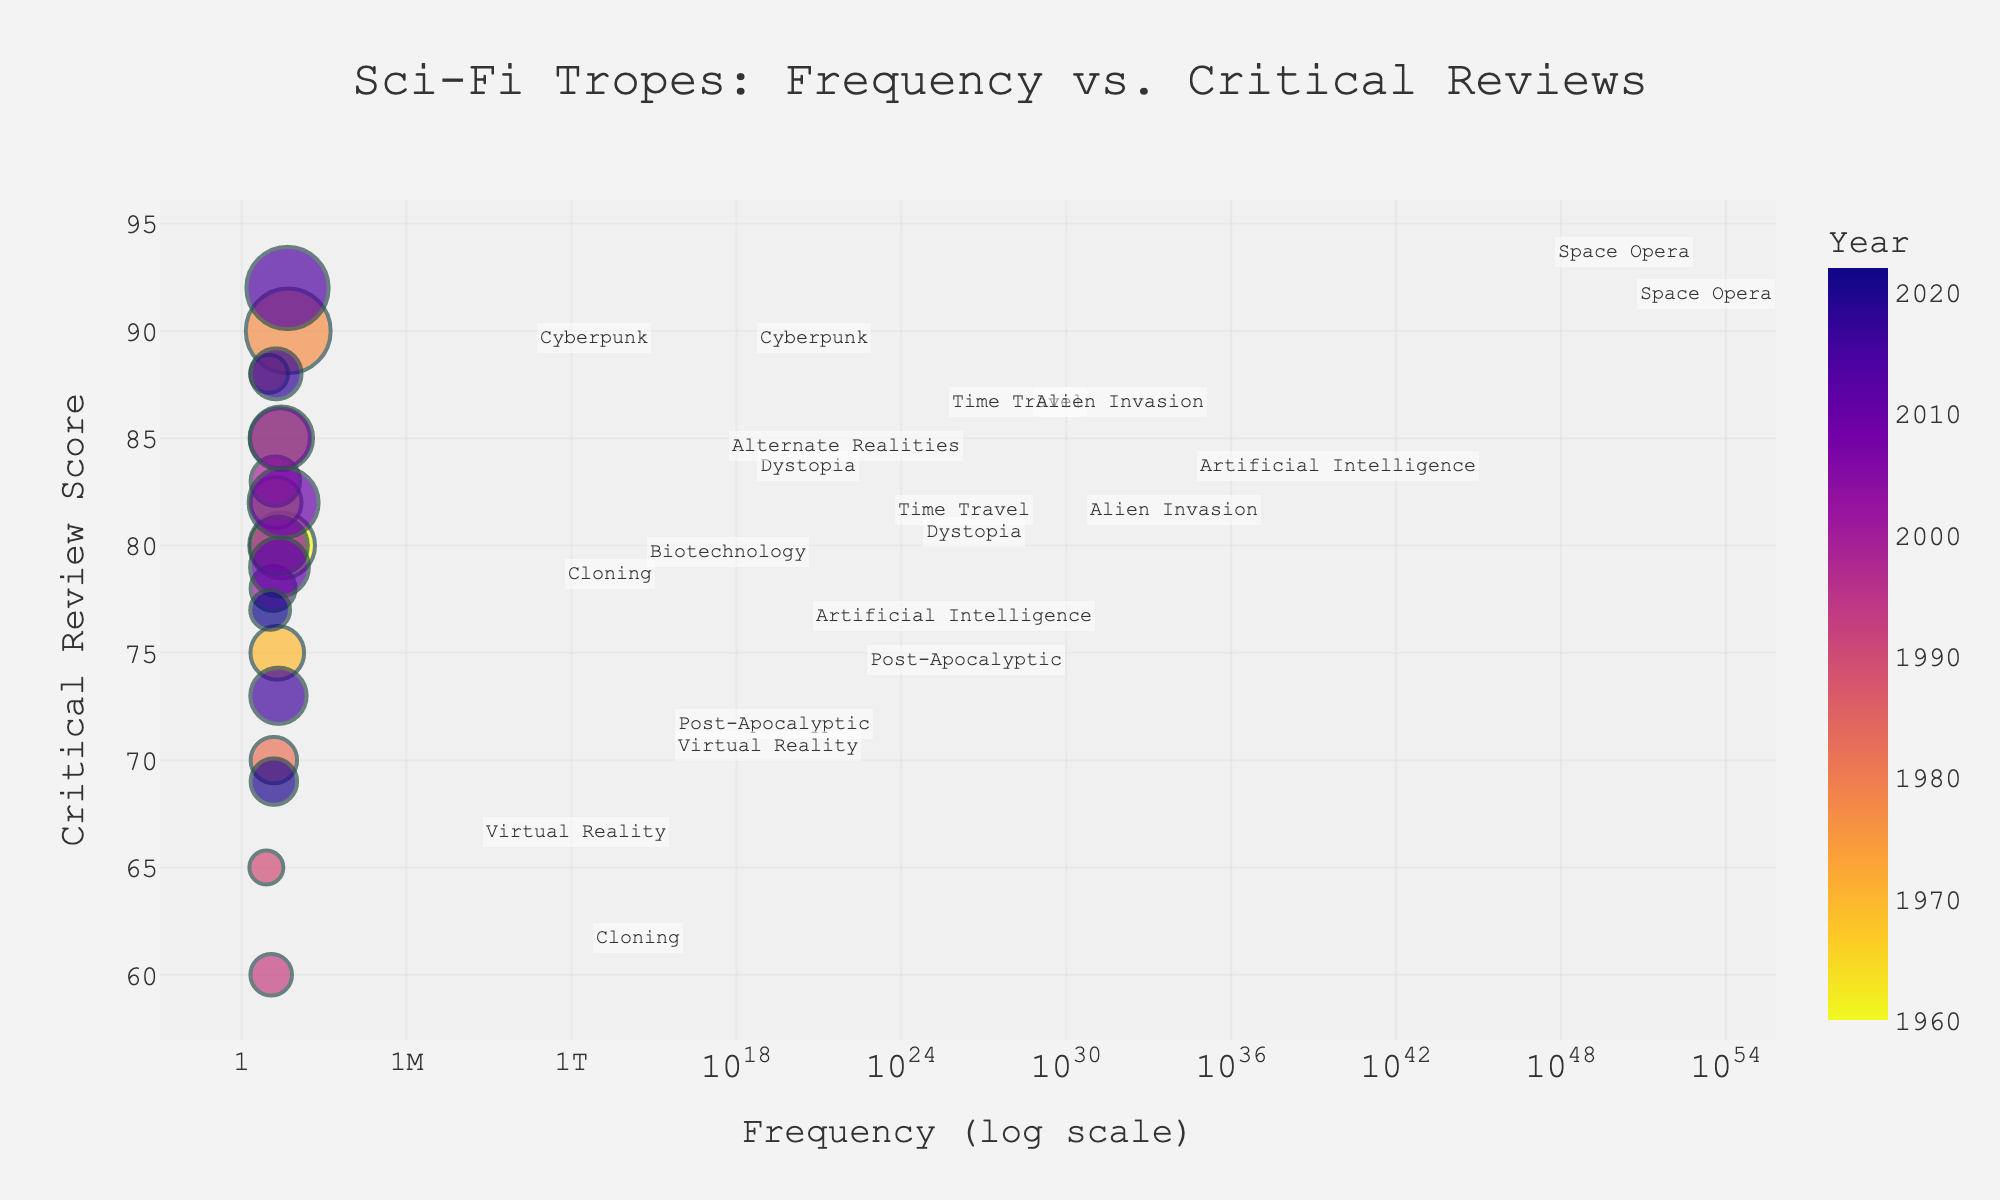What's the title of the scatter plot? The title of the plot is displayed prominently at the top center of the figure.
Answer: "Sci-Fi Tropes: Frequency vs. Critical Reviews" What are the axes titles in the scatter plot? The x-axis and y-axis titles are labeled clearly near the respective axes.
Answer: Frequency (log scale), Critical Review Score How many data points are there for the trope "Time Travel"? Identify all data points labeled as "Time Travel" by looking at the annotations next to the markers.
Answer: 2 Which trope has the highest critical review score, and what is that score? Look for the data point with the highest position on the y-axis and check the annotation for the trope's name and score.
Answer: Space Opera with a score of 92 Which year has the highest number of data points shown in the plot? Count the data points represented by each year to identify the year with the most points.
Answer: 1960 What is the average critical review score for "Cyberpunk"? Identify the data points for "Cyberpunk," sum their critical review scores, and divide by the number of points.
Answer: (88 + 88)/2 = 88 Which trope has the smallest frequency in the most recent year, and what is that frequency? Look at the data points for the most recent year (2022) and identify the smallest frequency from the annotations.
Answer: Cloning with a frequency of 11 Compare the frequencies of "Alien Invasion" between 1960 and 2007. Which year had a higher frequency? Identify the data points for "Alien Invasion" in both years and compare their frequencies.
Answer: 1960 had 30, 2007 had 28; 1960 had a higher frequency What is the difference in critical review scores between "Virtual Reality" from 2010 and 2020? Identify the data points for "Virtual Reality" in 2010 and 2020 and subtract their critical review scores.
Answer: 82 - 69 = 13 Which data point represents the trope with the lowest critical review score, and what is the frequency and year for that data point? Look for the lowest position on the y-axis to identify the trope, then read the frequency and year from the annotation.
Answer: Cloning, frequency of 12, year 1993 